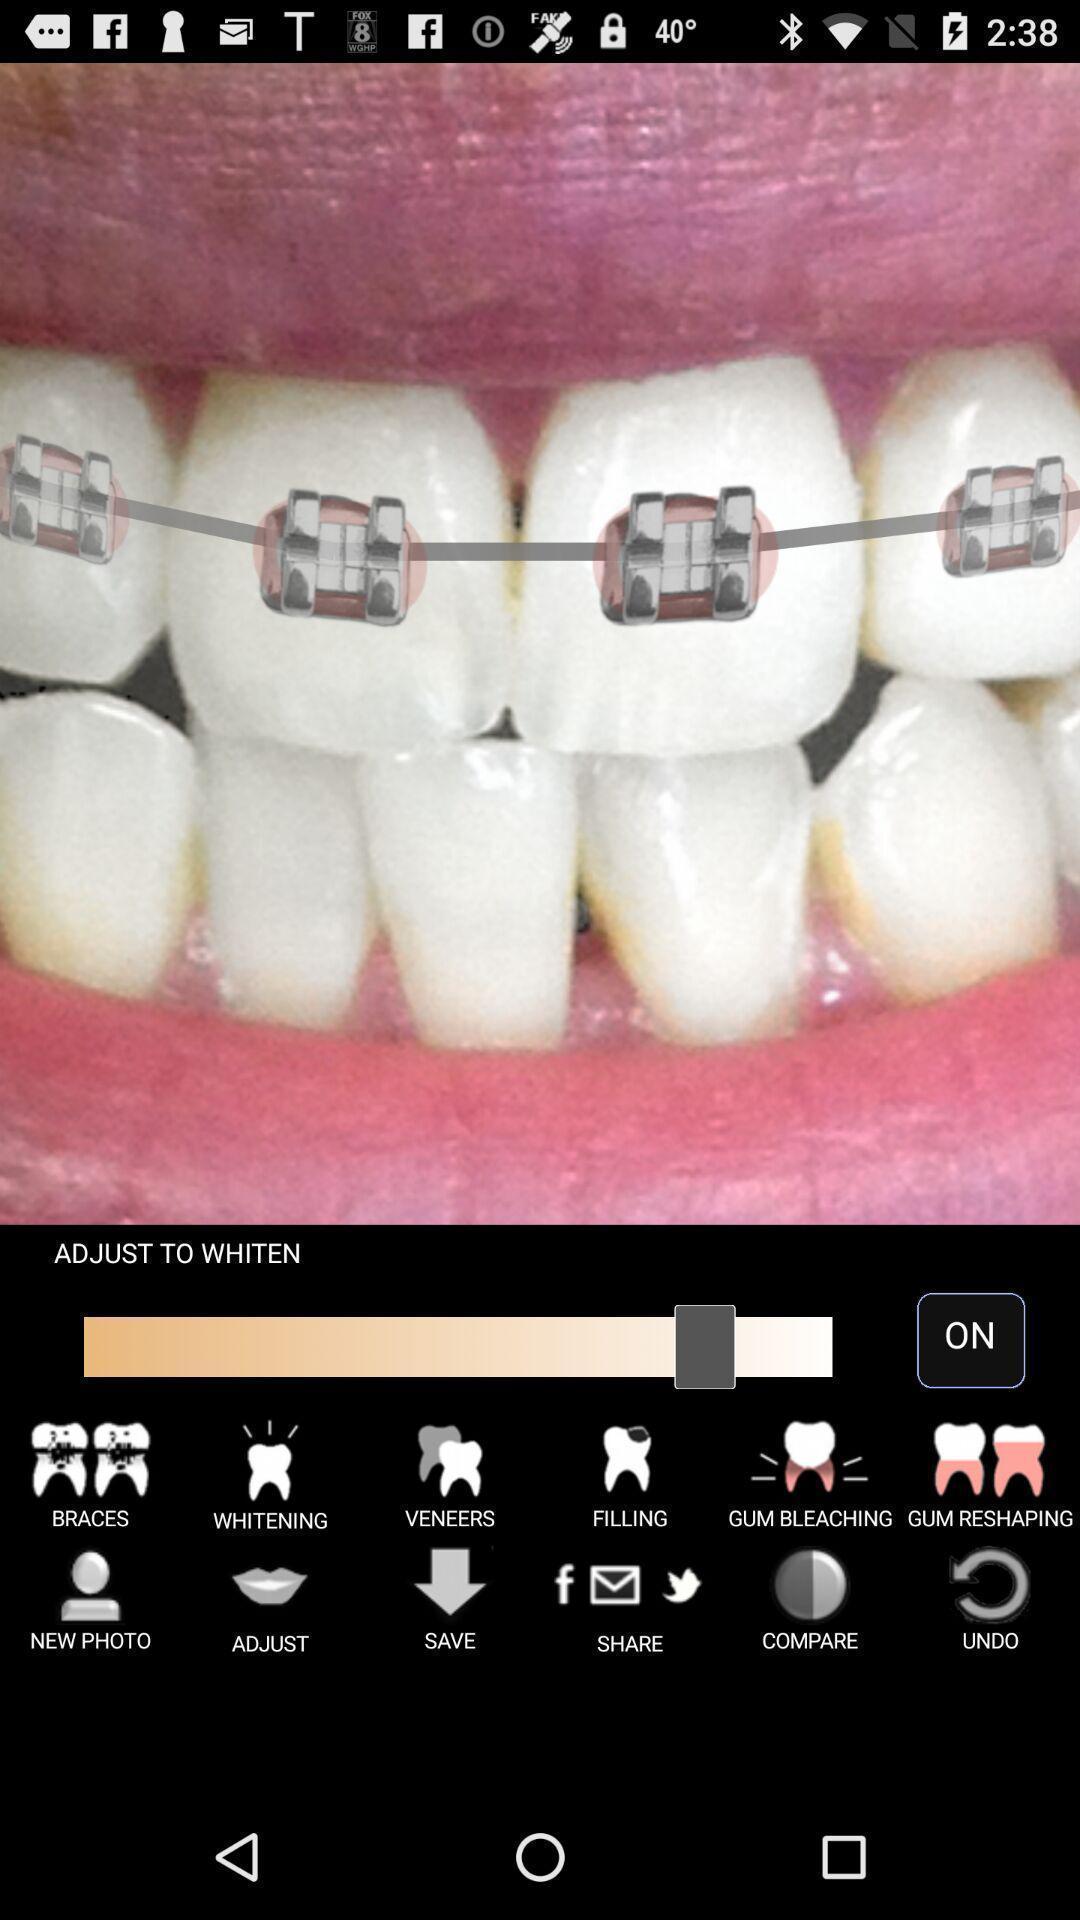Summarize the information in this screenshot. Page showing edit options of an image on an app. 